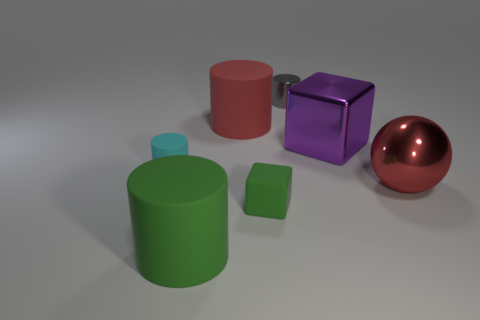Is the number of green matte blocks that are right of the red metallic ball the same as the number of small cylinders behind the big red rubber cylinder?
Make the answer very short. No. There is a cyan cylinder behind the green block; how big is it?
Provide a short and direct response. Small. Is there anything else that has the same shape as the red metallic object?
Make the answer very short. No. There is a large cylinder that is the same color as the small matte block; what material is it?
Make the answer very short. Rubber. Are there the same number of cyan rubber cylinders that are in front of the red metal object and yellow matte objects?
Keep it short and to the point. Yes. Are there any tiny cyan rubber things right of the small cyan matte thing?
Your answer should be very brief. No. Is the shape of the tiny gray metal thing the same as the large red shiny object in front of the tiny gray metal cylinder?
Provide a short and direct response. No. There is a small cylinder that is the same material as the tiny cube; what color is it?
Your response must be concise. Cyan. The tiny metal object is what color?
Ensure brevity in your answer.  Gray. Does the red cylinder have the same material as the tiny cylinder that is left of the small shiny cylinder?
Provide a succinct answer. Yes. 